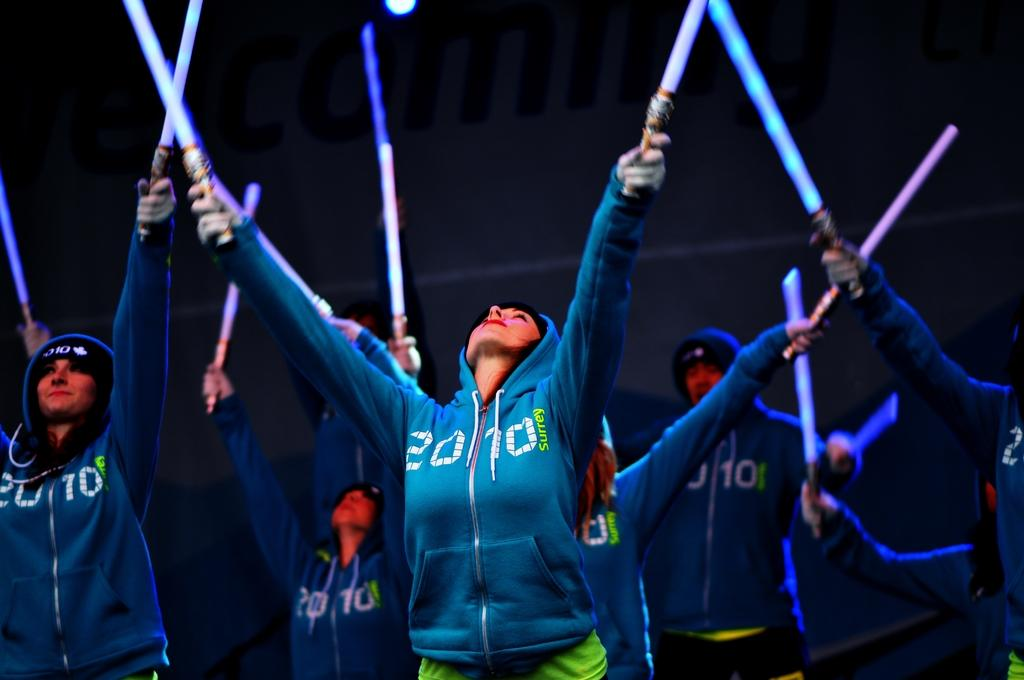What is the main subject of the image? The main subject of the image is a group of people. What are the people in the image doing? The people are standing in the image. What objects are the people holding in their hands? The people are holding laser lights in their hands. What type of slope can be seen in the image? There is no slope present in the image. How many dogs are visible in the image? There are no dogs present in the image. 